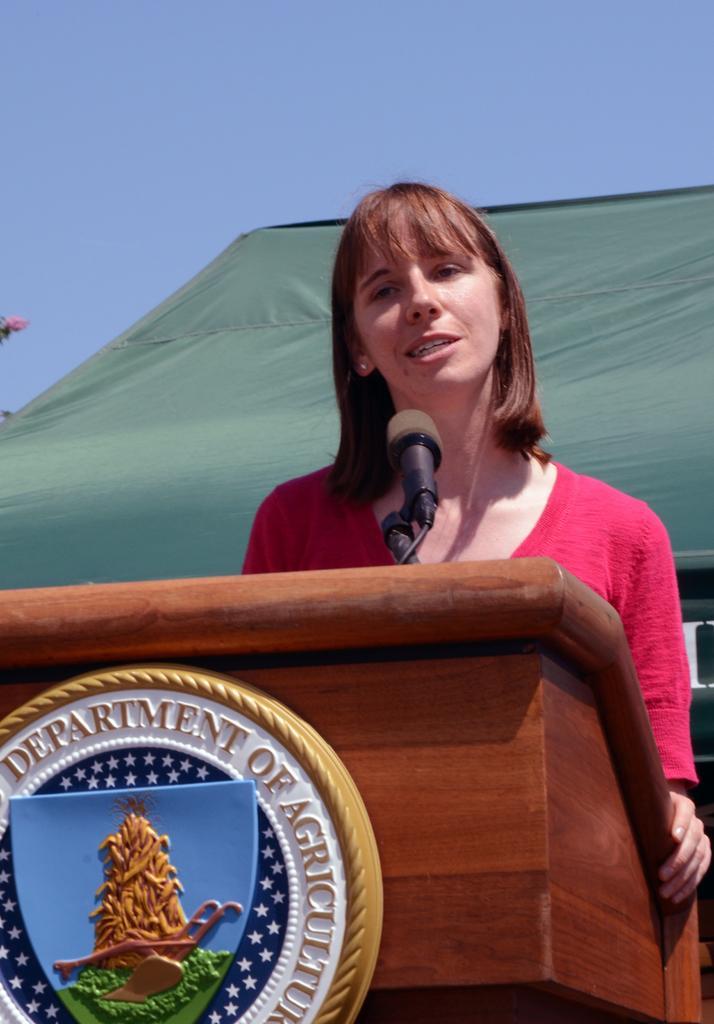In one or two sentences, can you explain what this image depicts? In the background we can see the sky and a green tent. On the left side of the picture it seems like a pink flower. In this picture we can see a woman standing near to a podium. On a podium we can see the information and a logo. We can see a mike. 